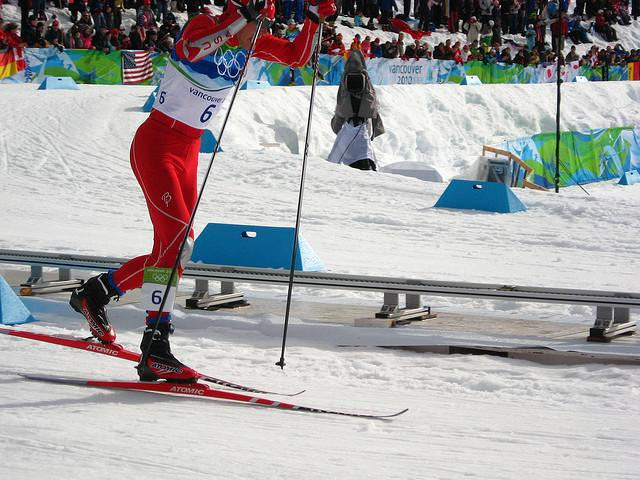What level of event is this?

Choices:
A) hobby
B) national
C) international
D) local international 